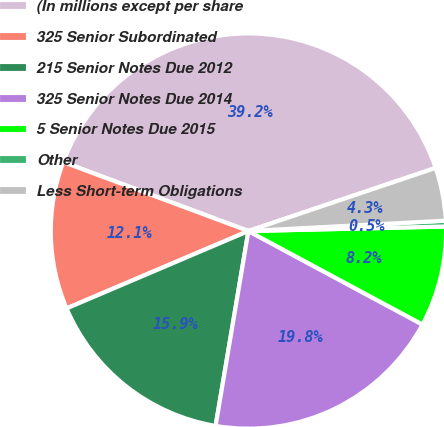Convert chart. <chart><loc_0><loc_0><loc_500><loc_500><pie_chart><fcel>(In millions except per share<fcel>325 Senior Subordinated<fcel>215 Senior Notes Due 2012<fcel>325 Senior Notes Due 2014<fcel>5 Senior Notes Due 2015<fcel>Other<fcel>Less Short-term Obligations<nl><fcel>39.15%<fcel>12.08%<fcel>15.94%<fcel>19.81%<fcel>8.21%<fcel>0.47%<fcel>4.34%<nl></chart> 